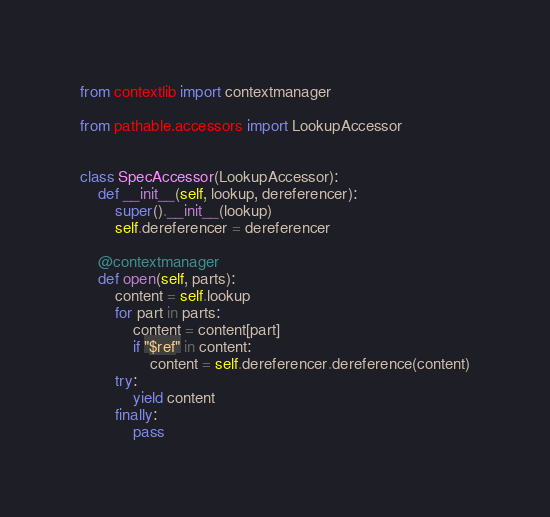Convert code to text. <code><loc_0><loc_0><loc_500><loc_500><_Python_>from contextlib import contextmanager

from pathable.accessors import LookupAccessor


class SpecAccessor(LookupAccessor):
    def __init__(self, lookup, dereferencer):
        super().__init__(lookup)
        self.dereferencer = dereferencer

    @contextmanager
    def open(self, parts):
        content = self.lookup
        for part in parts:
            content = content[part]
            if "$ref" in content:
                content = self.dereferencer.dereference(content)
        try:
            yield content
        finally:
            pass
</code> 